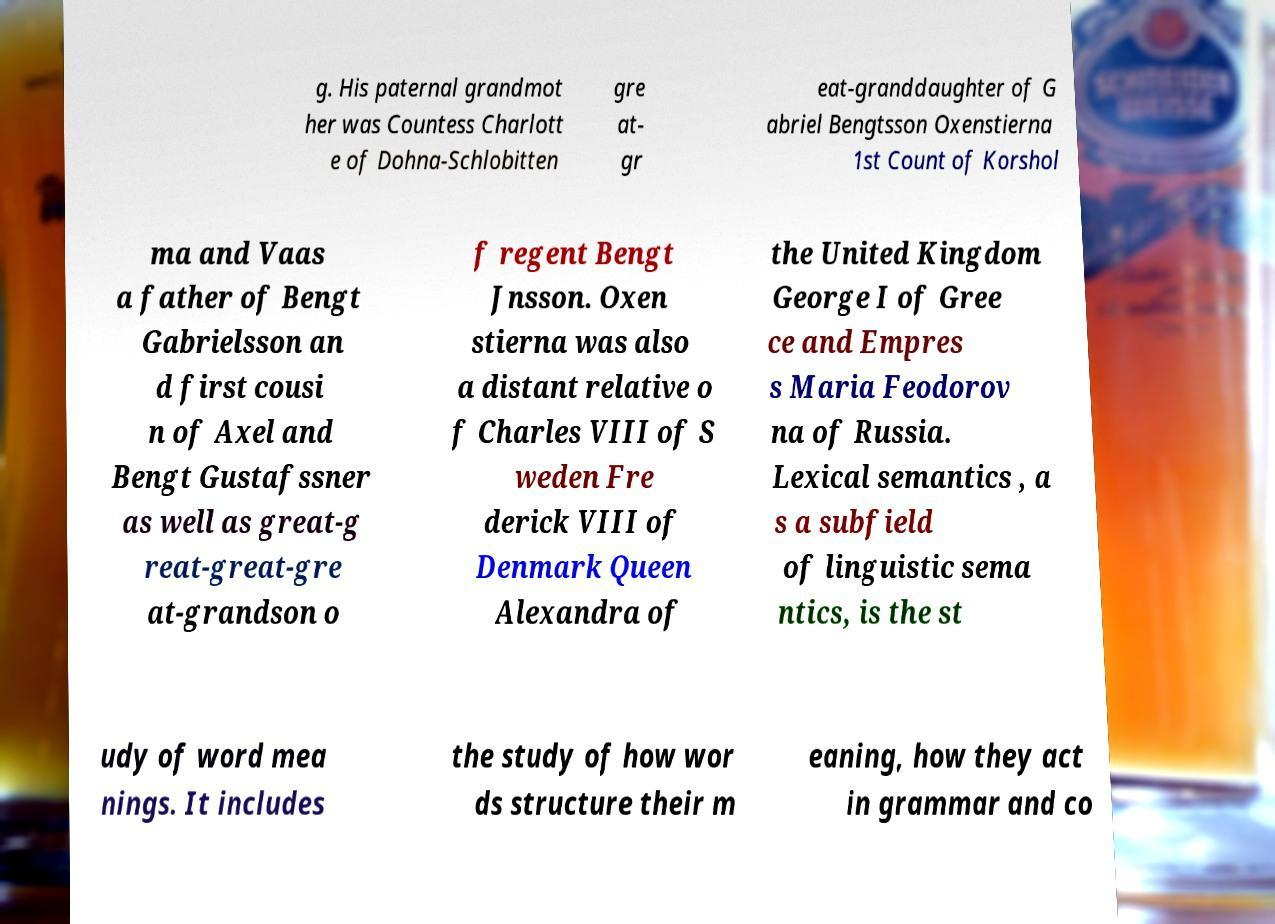Can you accurately transcribe the text from the provided image for me? g. His paternal grandmot her was Countess Charlott e of Dohna-Schlobitten gre at- gr eat-granddaughter of G abriel Bengtsson Oxenstierna 1st Count of Korshol ma and Vaas a father of Bengt Gabrielsson an d first cousi n of Axel and Bengt Gustafssner as well as great-g reat-great-gre at-grandson o f regent Bengt Jnsson. Oxen stierna was also a distant relative o f Charles VIII of S weden Fre derick VIII of Denmark Queen Alexandra of the United Kingdom George I of Gree ce and Empres s Maria Feodorov na of Russia. Lexical semantics , a s a subfield of linguistic sema ntics, is the st udy of word mea nings. It includes the study of how wor ds structure their m eaning, how they act in grammar and co 